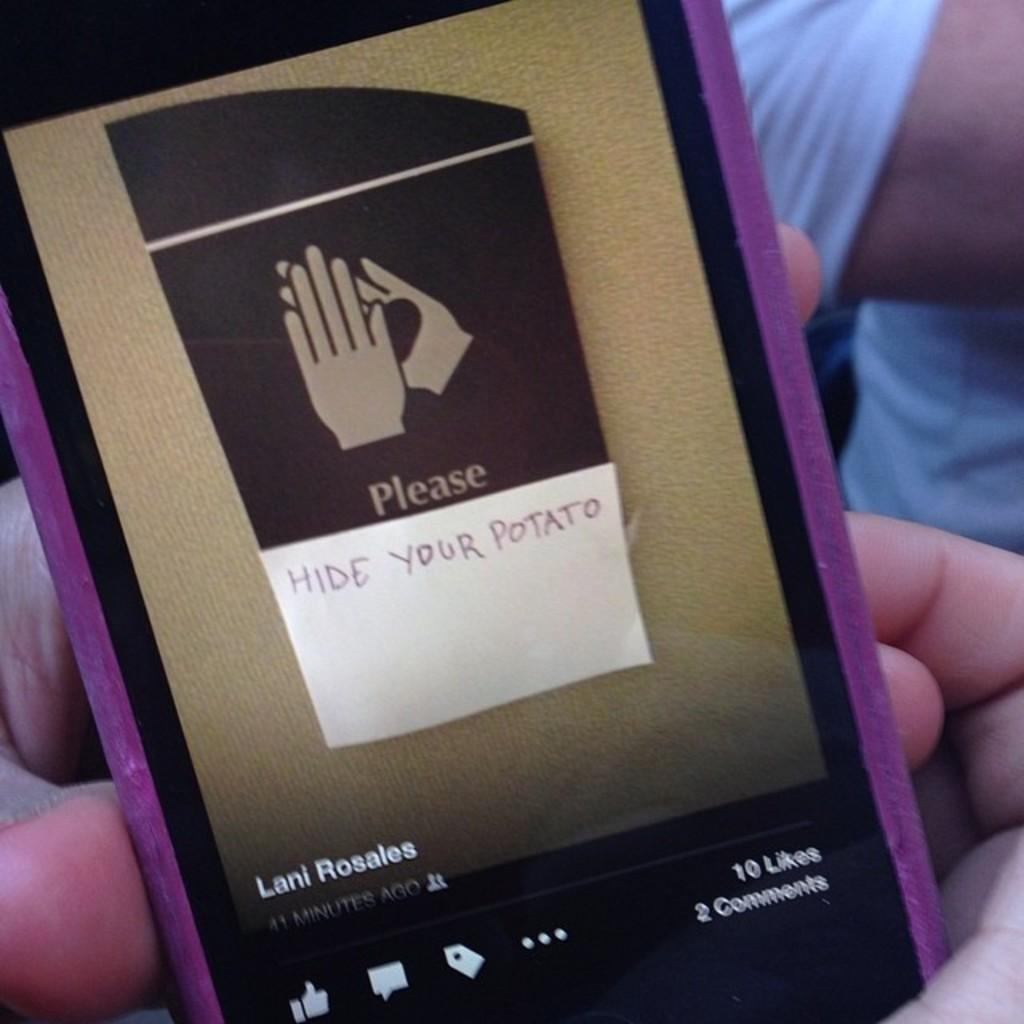How would you summarize this image in a sentence or two? In this image we can see the hands of a person holding a device containing some text on its screen. On the backside we can see a person. 